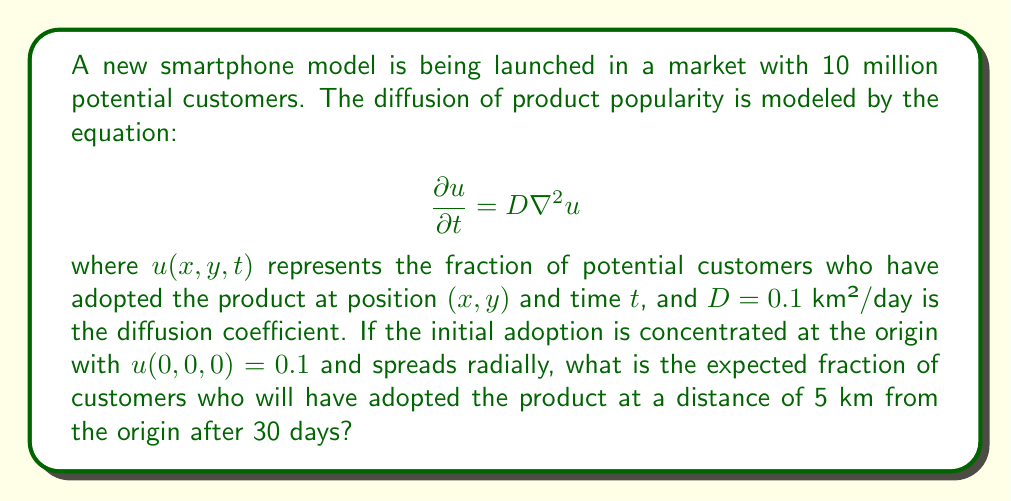Give your solution to this math problem. To solve this problem, we need to use the solution for the 2D diffusion equation with a point source:

1. The solution for a point source in 2D is given by:

   $$u(r,t) = \frac{M}{4\pi Dt} e^{-\frac{r^2}{4Dt}}$$

   where $M$ is the initial total amount (in this case, the initial fraction of adopters multiplied by the total market size), $r$ is the radial distance, and $t$ is time.

2. Calculate $M$:
   $M = 0.1 \times 10,000,000 = 1,000,000$

3. Substitute the given values:
   $D = 0.1$ km²/day
   $r = 5$ km
   $t = 30$ days

4. Plug these into the equation:

   $$u(5,30) = \frac{1,000,000}{4\pi \times 0.1 \times 30} e^{-\frac{5^2}{4 \times 0.1 \times 30}}$$

5. Simplify:
   $$u(5,30) = \frac{1,000,000}{37.7} e^{-\frac{25}{12}}$$

6. Calculate:
   $$u(5,30) \approx 0.0231$$

7. This represents the fraction of potential customers who have adopted the product at a distance of 5 km from the origin after 30 days.
Answer: 0.0231 or 2.31% 